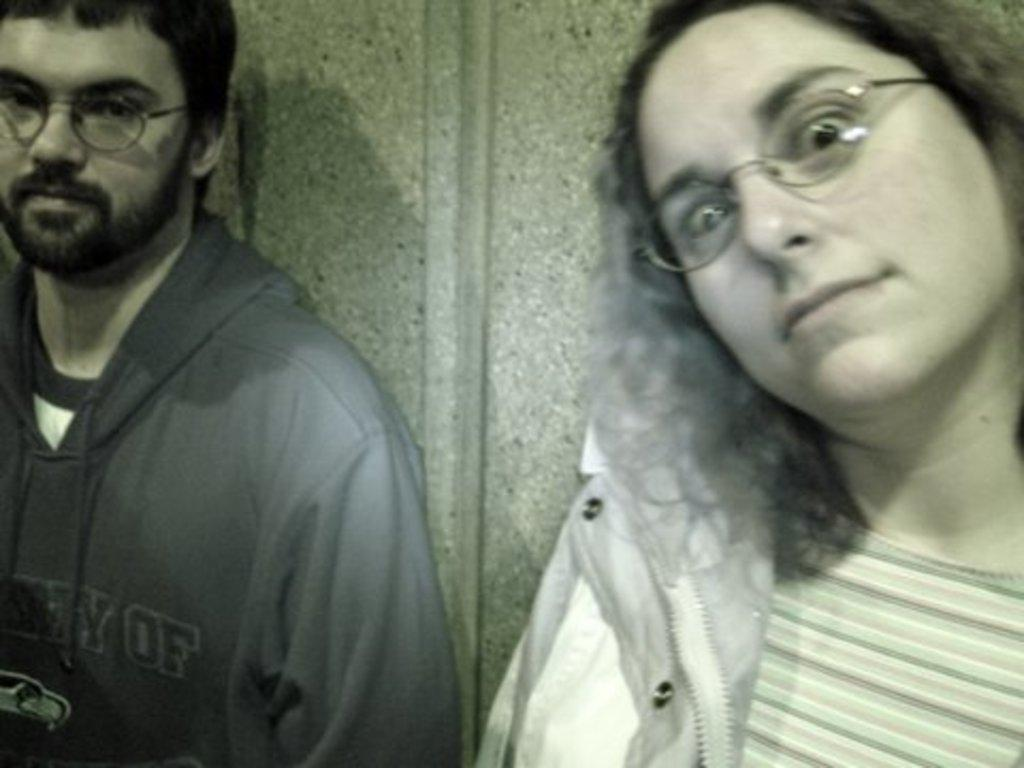Who is present in the image? There is a woman and men in the image. What are the woman and men doing in the image? The woman and men are watching something. What are the woman and men wearing in the image? The woman and men are wearing glasses. What can be seen in the background of the image? There is a wall in the background of the image. What type of glove is the woman wearing in the image? There is no glove present in the image; the woman and men are wearing glasses. 